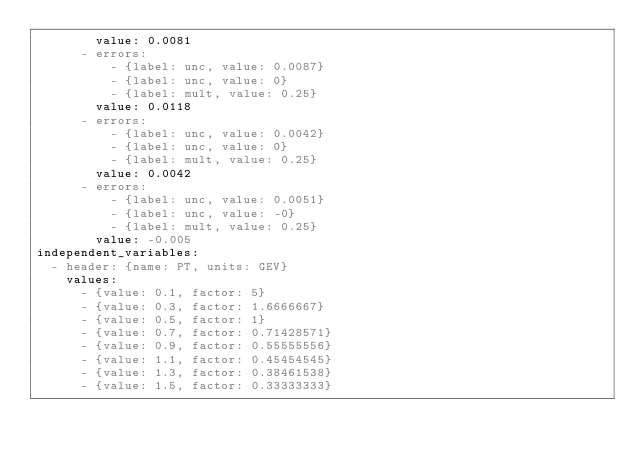Convert code to text. <code><loc_0><loc_0><loc_500><loc_500><_YAML_>        value: 0.0081
      - errors:
          - {label: unc, value: 0.0087}
          - {label: unc, value: 0}
          - {label: mult, value: 0.25}
        value: 0.0118
      - errors:
          - {label: unc, value: 0.0042}
          - {label: unc, value: 0}
          - {label: mult, value: 0.25}
        value: 0.0042
      - errors:
          - {label: unc, value: 0.0051}
          - {label: unc, value: -0}
          - {label: mult, value: 0.25}
        value: -0.005
independent_variables:
  - header: {name: PT, units: GEV}
    values:
      - {value: 0.1, factor: 5}
      - {value: 0.3, factor: 1.6666667}
      - {value: 0.5, factor: 1}
      - {value: 0.7, factor: 0.71428571}
      - {value: 0.9, factor: 0.55555556}
      - {value: 1.1, factor: 0.45454545}
      - {value: 1.3, factor: 0.38461538}
      - {value: 1.5, factor: 0.33333333}</code> 